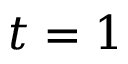Convert formula to latex. <formula><loc_0><loc_0><loc_500><loc_500>t = 1</formula> 